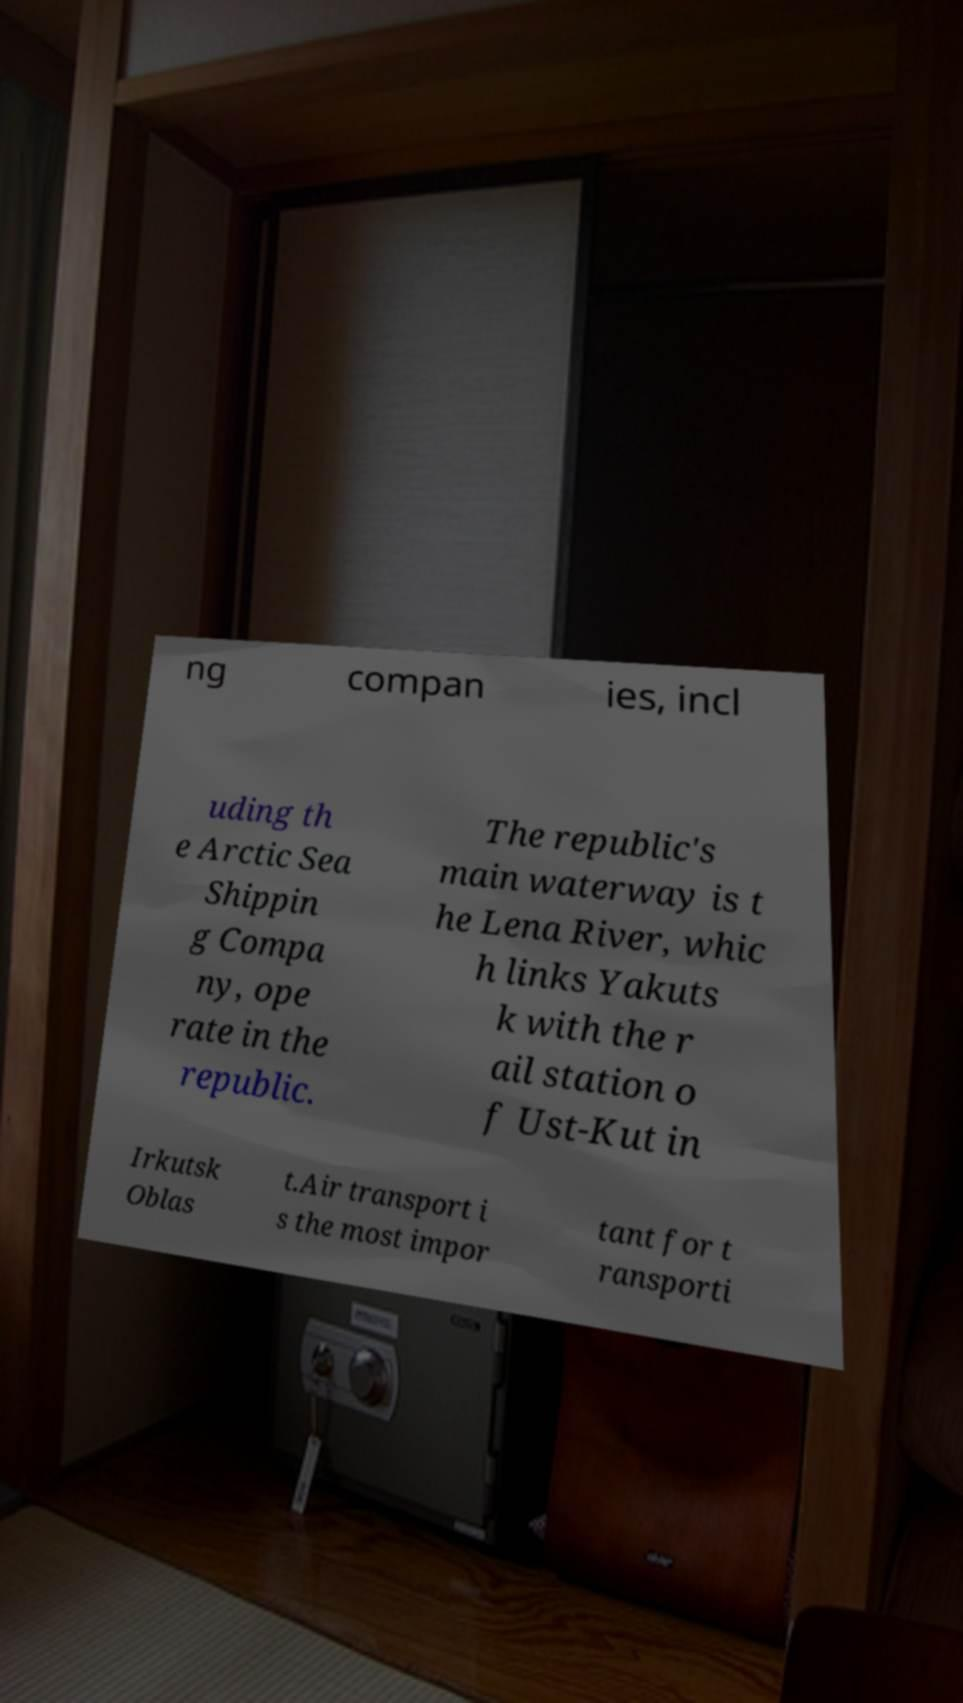There's text embedded in this image that I need extracted. Can you transcribe it verbatim? ng compan ies, incl uding th e Arctic Sea Shippin g Compa ny, ope rate in the republic. The republic's main waterway is t he Lena River, whic h links Yakuts k with the r ail station o f Ust-Kut in Irkutsk Oblas t.Air transport i s the most impor tant for t ransporti 